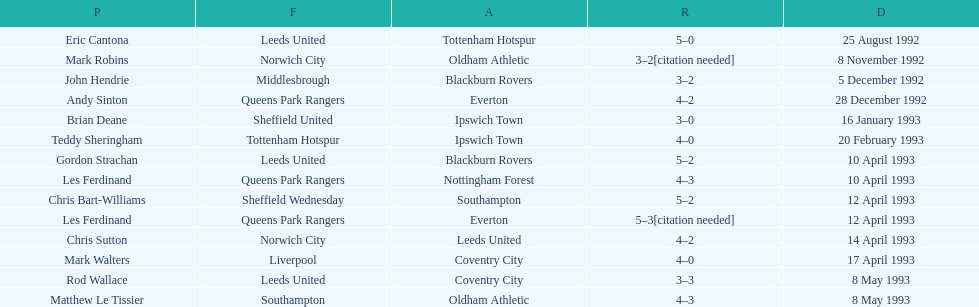Name the only player from france. Eric Cantona. 